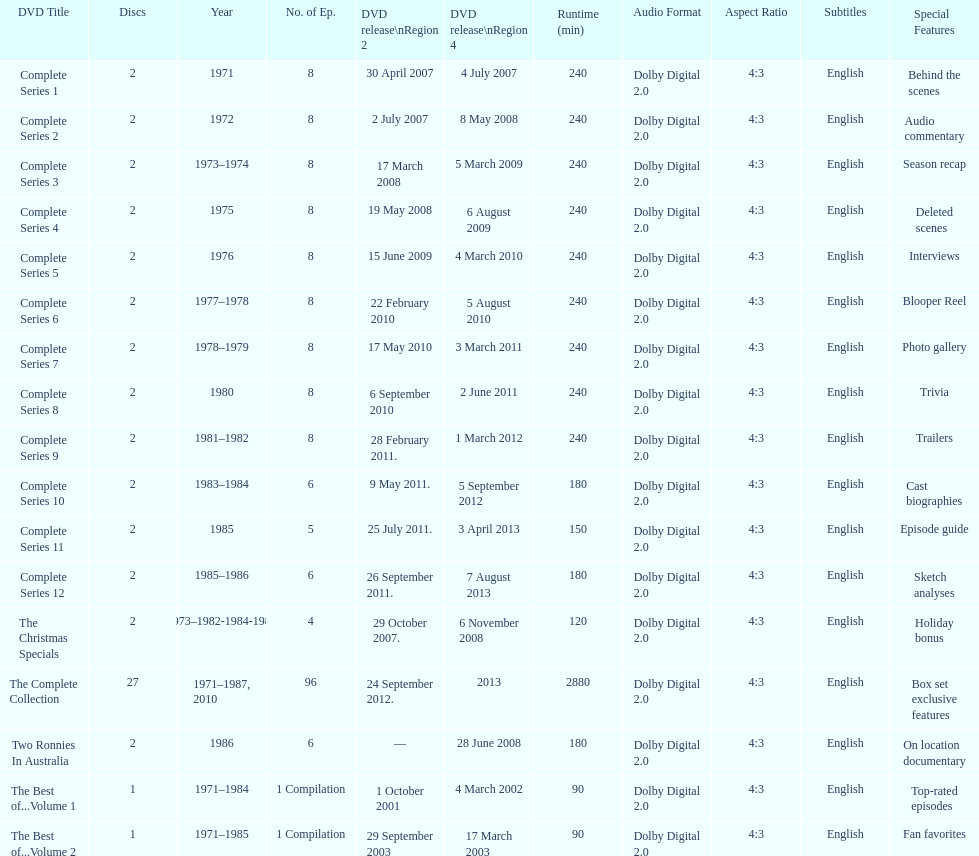What comes immediately after complete series 11? Complete Series 12. 